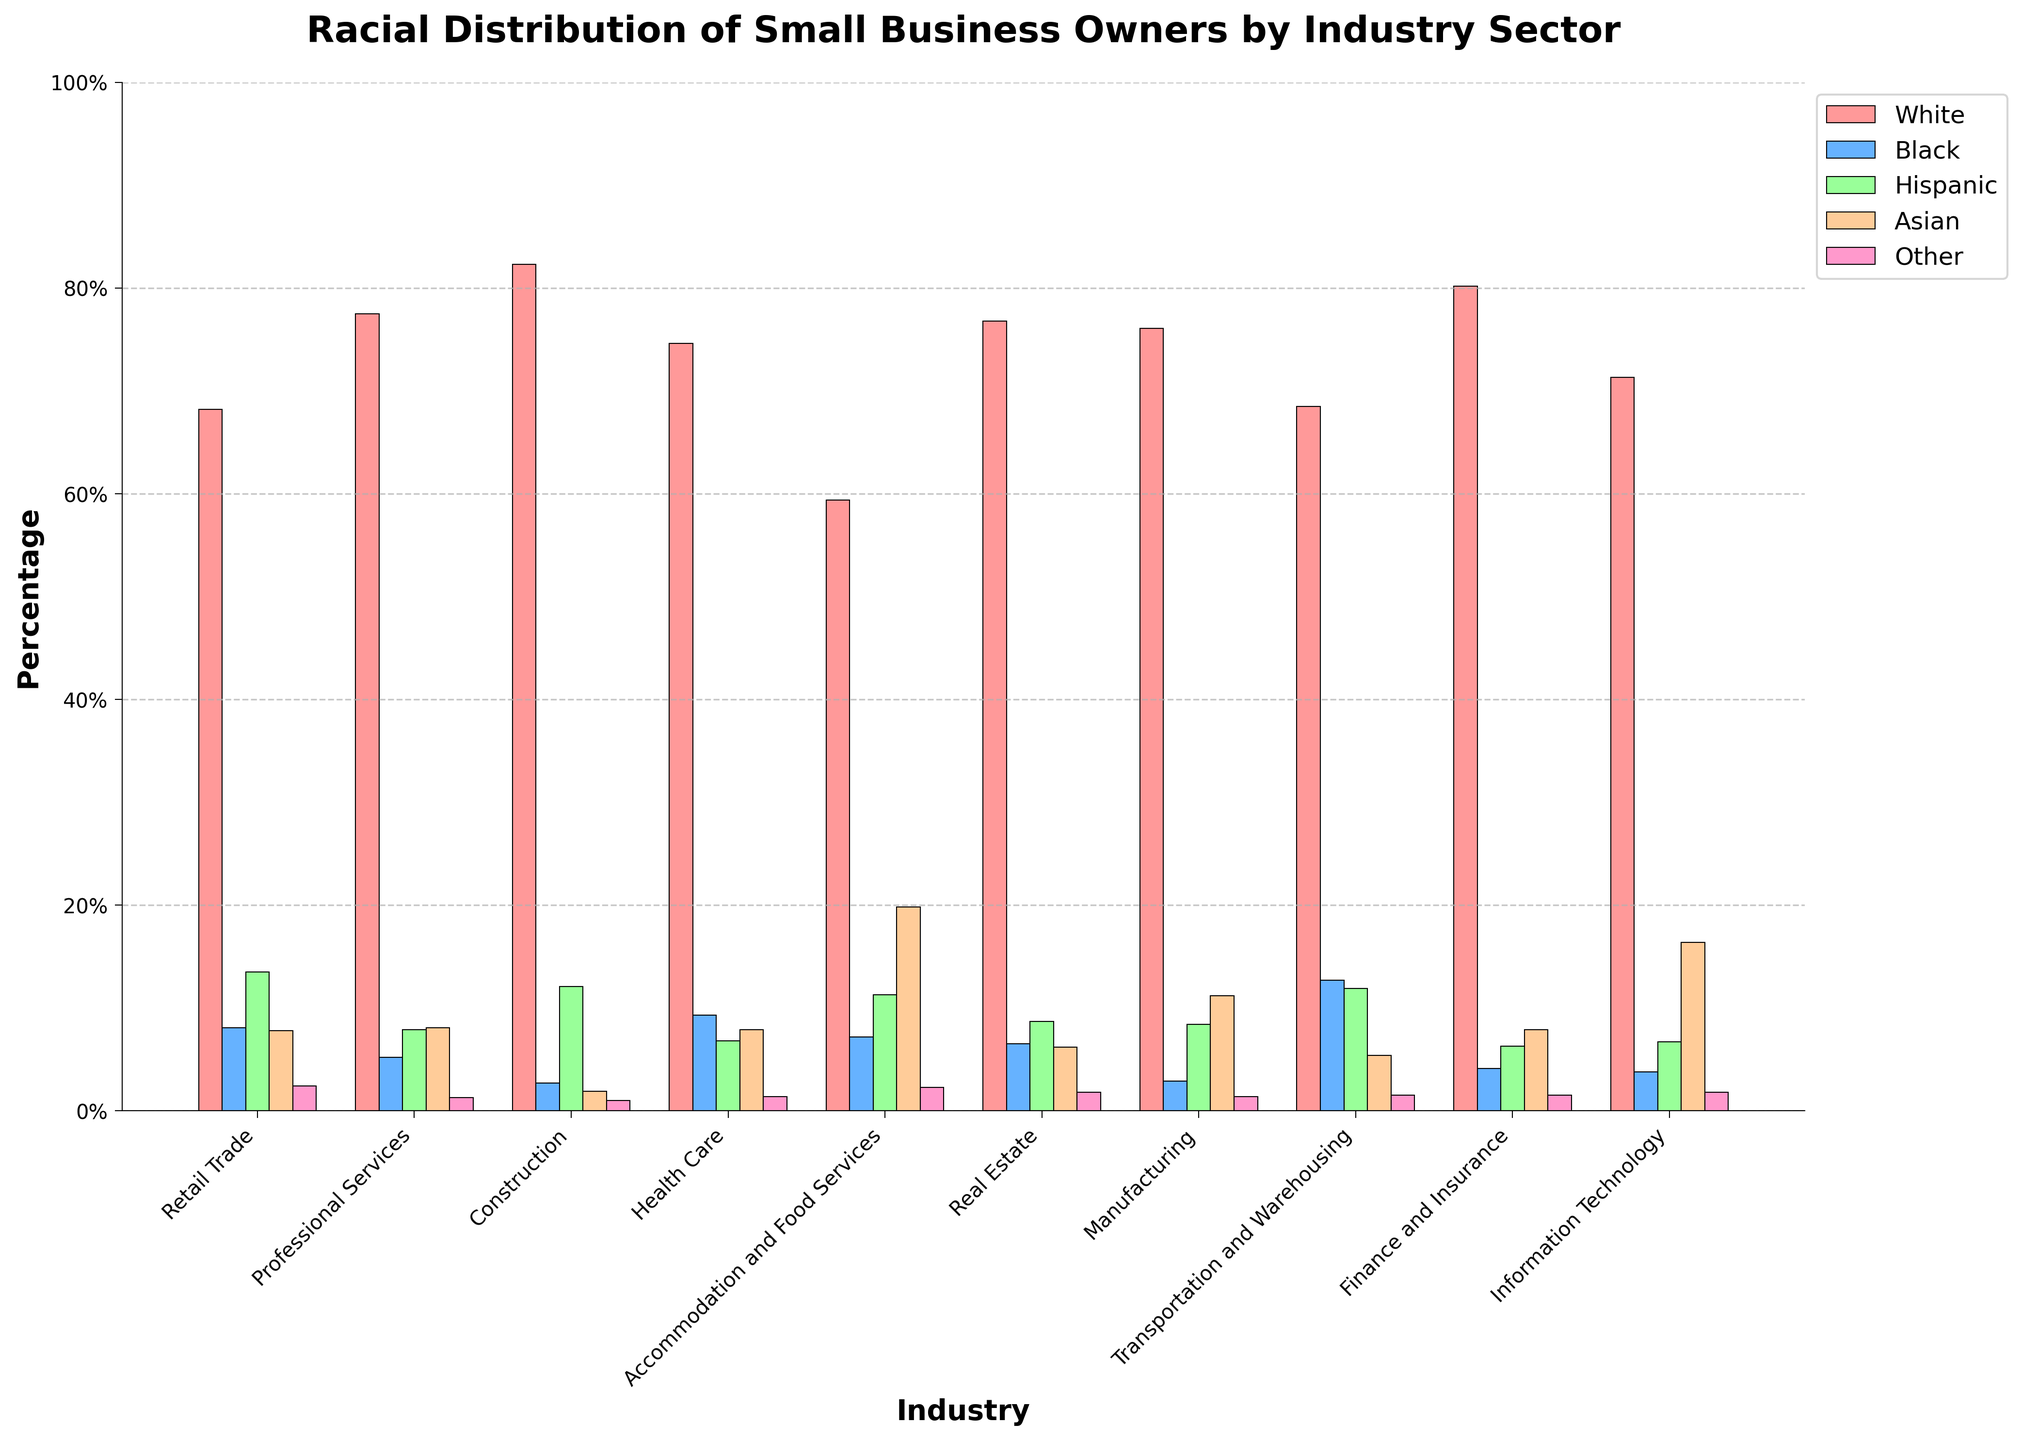What's the industry with the highest percentage of White small business owners? By examining the highest bars for the "White" category, we see that the Construction industry has the tallest bar, indicating the highest percentage.
Answer: Construction Which industry has the smallest percentage of Hispanic small business owners? The shortest bar in the "Hispanic" category is found in the Professional Services industry.
Answer: Professional Services Compare the percentage of Black small business owners in Transportation and Warehousing to those in White small business owners in Accommodation and Food Services. Which is higher? The percentage of Black small business owners in Transportation and Warehousing is 12.7%, while the percentage of White small business owners in Accommodation and Food Services is 59.4%. Therefore, the percentage of White owners in Accommodation and Food Services is higher.
Answer: White owners in Accommodation and Food Services What is the average percentage of Asian small business owners across all industries shown? Sum the percentages of Asian small business owners across all industries and divide by the number of industries. Calculation: (7.8 + 8.1 + 1.9 + 7.9 + 19.8 + 6.2 + 11.2 + 5.4 + 7.9 + 16.4) / 10 = 9.26%.
Answer: 9.26% In which industry is the proportion of Black small business owners closest to the proportion of Hispanic small business owners? By comparing each industry's percentage of Black and Hispanic small business owners, the Health Care industry shows the closest percentages: 9.3% Black and 6.8% Hispanic.
Answer: Health Care Which industry has the most evenly distributed percentages among the racial categories? An even distribution means the bars for all racial groups are relatively similar in height. Accommodation and Food Services shows a more balanced distribution compared to others.
Answer: Accommodation and Food Services What is the total percentage of Other small business owners across all industries? Sum the percentages of Other small business owners: 2.4 + 1.3 + 1.0 + 1.4 + 2.3 + 1.8 + 1.4 + 1.5 + 1.5 + 1.8 = 16.4%.
Answer: 16.4% Compare the percentage of Asian small business owners in the Information Technology industry to the percentage in Manufacturing. Which is higher, and by how much? The percentage of Asian small business owners in Information Technology is 16.4%, while in Manufacturing it is 11.2%. The difference is 16.4% - 11.2% = 5.2%.
Answer: Information Technology by 5.2% Which two industries have the highest combined percentage of Hispanic small business owners? Find the two highest percentages in the Hispanic category: Retail Trade (13.5%) and Construction (12.1%). Their combined percentage is 13.5% + 12.1% = 25.6%.
Answer: Retail Trade and Construction What is the difference between the highest and lowest percentages of White small business owners across all industries? The highest percentage is in Construction (82.3%) and the lowest is in Accommodation and Food Services (59.4%). The difference is 82.3% - 59.4% = 22.9%.
Answer: 22.9% 